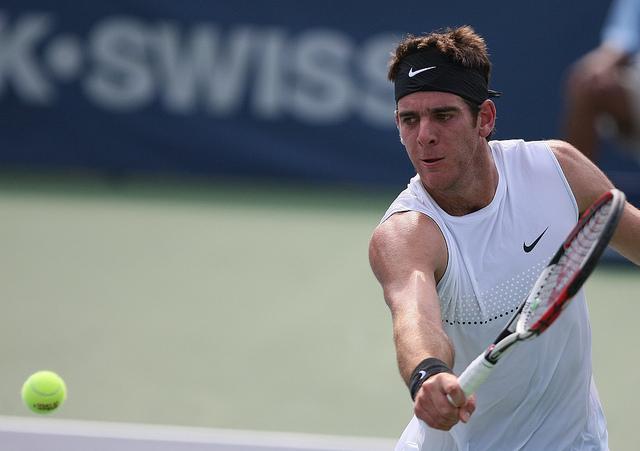What game is the man playing?
Write a very short answer. Tennis. What famous athlete is playing tennis in the photo?
Be succinct. Pete sampras. Is this image copyrighted?
Answer briefly. No. What logo is on his shirt?
Short answer required. Nike. What is about to happen in the game?
Short answer required. Ball will be hit. Who is this?
Answer briefly. Tennis player. Do you see a face?
Keep it brief. Yes. 